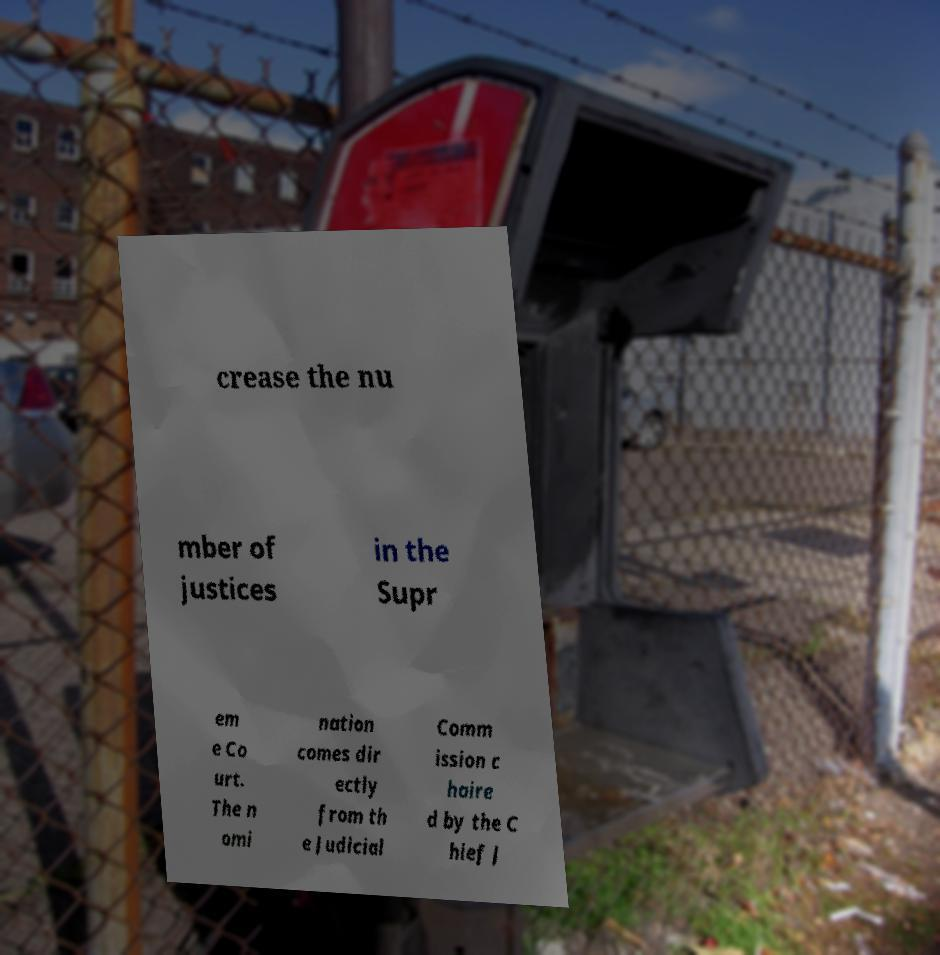Can you read and provide the text displayed in the image?This photo seems to have some interesting text. Can you extract and type it out for me? crease the nu mber of justices in the Supr em e Co urt. The n omi nation comes dir ectly from th e Judicial Comm ission c haire d by the C hief J 